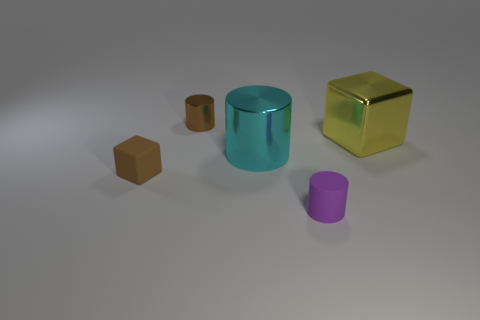What colors are featured in the image, and which one is the most vibrant? The image presents a palette of colors including brown, teal, gold, and purple. The gold cube stands out as the most vibrant due to its bright, reflective quality. 